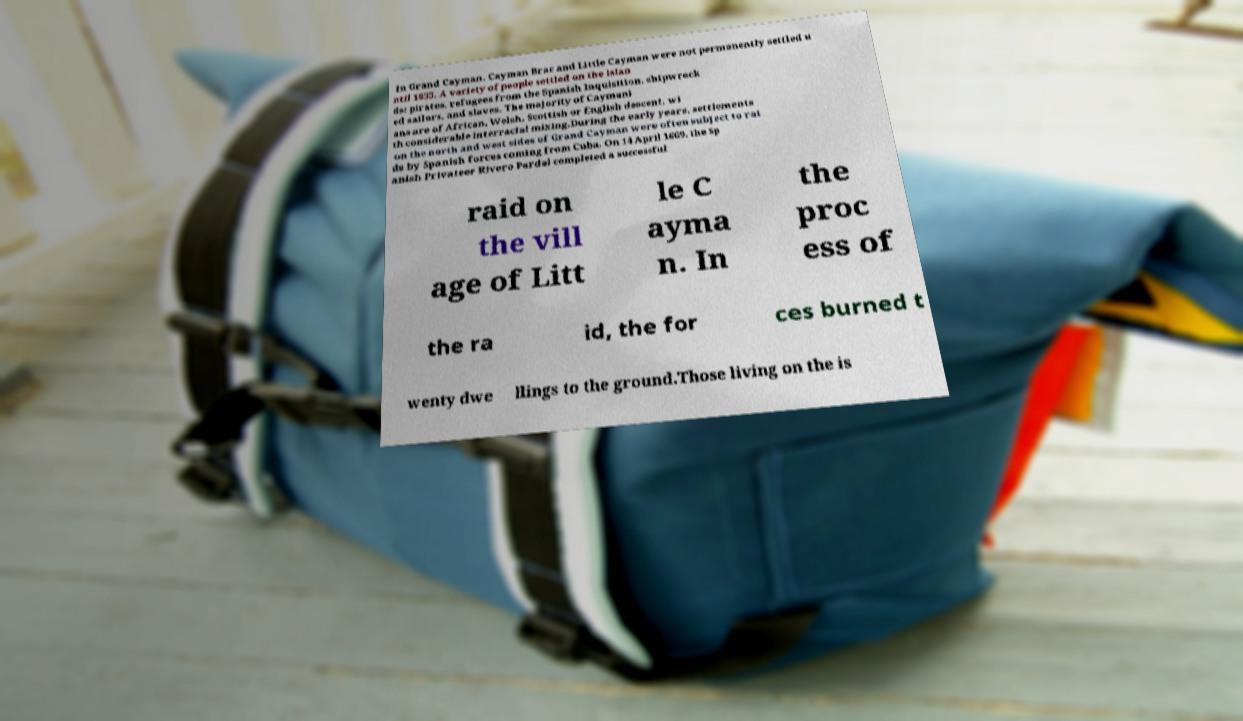Could you assist in decoding the text presented in this image and type it out clearly? in Grand Cayman. Cayman Brac and Little Cayman were not permanently settled u ntil 1833. A variety of people settled on the islan ds: pirates, refugees from the Spanish Inquisition, shipwreck ed sailors, and slaves. The majority of Caymani ans are of African, Welsh, Scottish or English descent, wi th considerable interracial mixing.During the early years, settlements on the north and west sides of Grand Cayman were often subject to rai ds by Spanish forces coming from Cuba. On 14 April 1669, the Sp anish Privateer Rivero Pardal completed a successful raid on the vill age of Litt le C ayma n. In the proc ess of the ra id, the for ces burned t wenty dwe llings to the ground.Those living on the is 